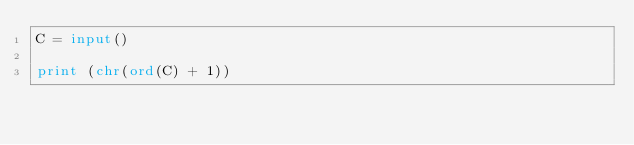Convert code to text. <code><loc_0><loc_0><loc_500><loc_500><_Python_>C = input()

print (chr(ord(C) + 1))




</code> 